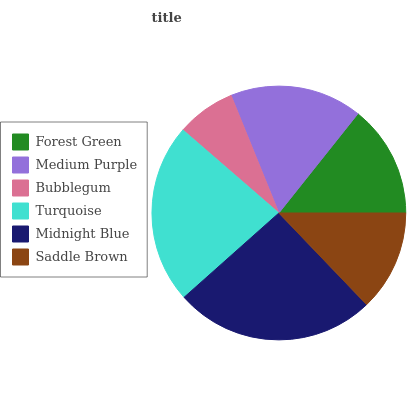Is Bubblegum the minimum?
Answer yes or no. Yes. Is Midnight Blue the maximum?
Answer yes or no. Yes. Is Medium Purple the minimum?
Answer yes or no. No. Is Medium Purple the maximum?
Answer yes or no. No. Is Medium Purple greater than Forest Green?
Answer yes or no. Yes. Is Forest Green less than Medium Purple?
Answer yes or no. Yes. Is Forest Green greater than Medium Purple?
Answer yes or no. No. Is Medium Purple less than Forest Green?
Answer yes or no. No. Is Medium Purple the high median?
Answer yes or no. Yes. Is Forest Green the low median?
Answer yes or no. Yes. Is Bubblegum the high median?
Answer yes or no. No. Is Turquoise the low median?
Answer yes or no. No. 